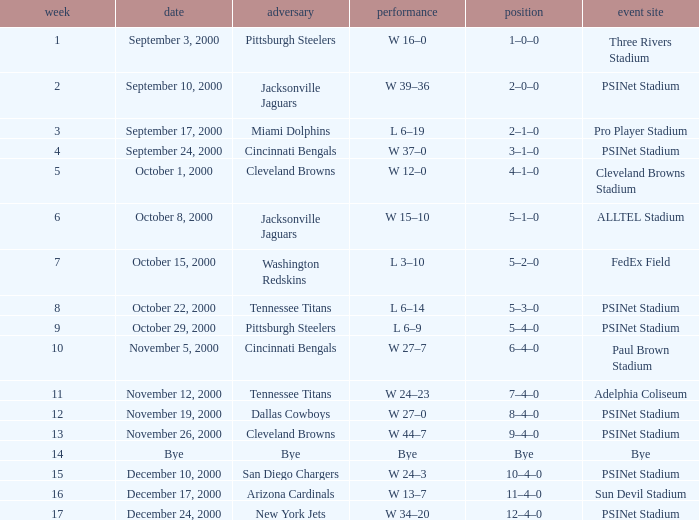What game site has a result of bye? Bye. Write the full table. {'header': ['week', 'date', 'adversary', 'performance', 'position', 'event site'], 'rows': [['1', 'September 3, 2000', 'Pittsburgh Steelers', 'W 16–0', '1–0–0', 'Three Rivers Stadium'], ['2', 'September 10, 2000', 'Jacksonville Jaguars', 'W 39–36', '2–0–0', 'PSINet Stadium'], ['3', 'September 17, 2000', 'Miami Dolphins', 'L 6–19', '2–1–0', 'Pro Player Stadium'], ['4', 'September 24, 2000', 'Cincinnati Bengals', 'W 37–0', '3–1–0', 'PSINet Stadium'], ['5', 'October 1, 2000', 'Cleveland Browns', 'W 12–0', '4–1–0', 'Cleveland Browns Stadium'], ['6', 'October 8, 2000', 'Jacksonville Jaguars', 'W 15–10', '5–1–0', 'ALLTEL Stadium'], ['7', 'October 15, 2000', 'Washington Redskins', 'L 3–10', '5–2–0', 'FedEx Field'], ['8', 'October 22, 2000', 'Tennessee Titans', 'L 6–14', '5–3–0', 'PSINet Stadium'], ['9', 'October 29, 2000', 'Pittsburgh Steelers', 'L 6–9', '5–4–0', 'PSINet Stadium'], ['10', 'November 5, 2000', 'Cincinnati Bengals', 'W 27–7', '6–4–0', 'Paul Brown Stadium'], ['11', 'November 12, 2000', 'Tennessee Titans', 'W 24–23', '7–4–0', 'Adelphia Coliseum'], ['12', 'November 19, 2000', 'Dallas Cowboys', 'W 27–0', '8–4–0', 'PSINet Stadium'], ['13', 'November 26, 2000', 'Cleveland Browns', 'W 44–7', '9–4–0', 'PSINet Stadium'], ['14', 'Bye', 'Bye', 'Bye', 'Bye', 'Bye'], ['15', 'December 10, 2000', 'San Diego Chargers', 'W 24–3', '10–4–0', 'PSINet Stadium'], ['16', 'December 17, 2000', 'Arizona Cardinals', 'W 13–7', '11–4–0', 'Sun Devil Stadium'], ['17', 'December 24, 2000', 'New York Jets', 'W 34–20', '12–4–0', 'PSINet Stadium']]} 